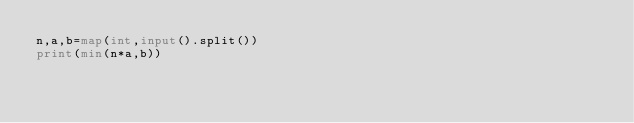Convert code to text. <code><loc_0><loc_0><loc_500><loc_500><_Python_>n,a,b=map(int,input().split())
print(min(n*a,b))</code> 